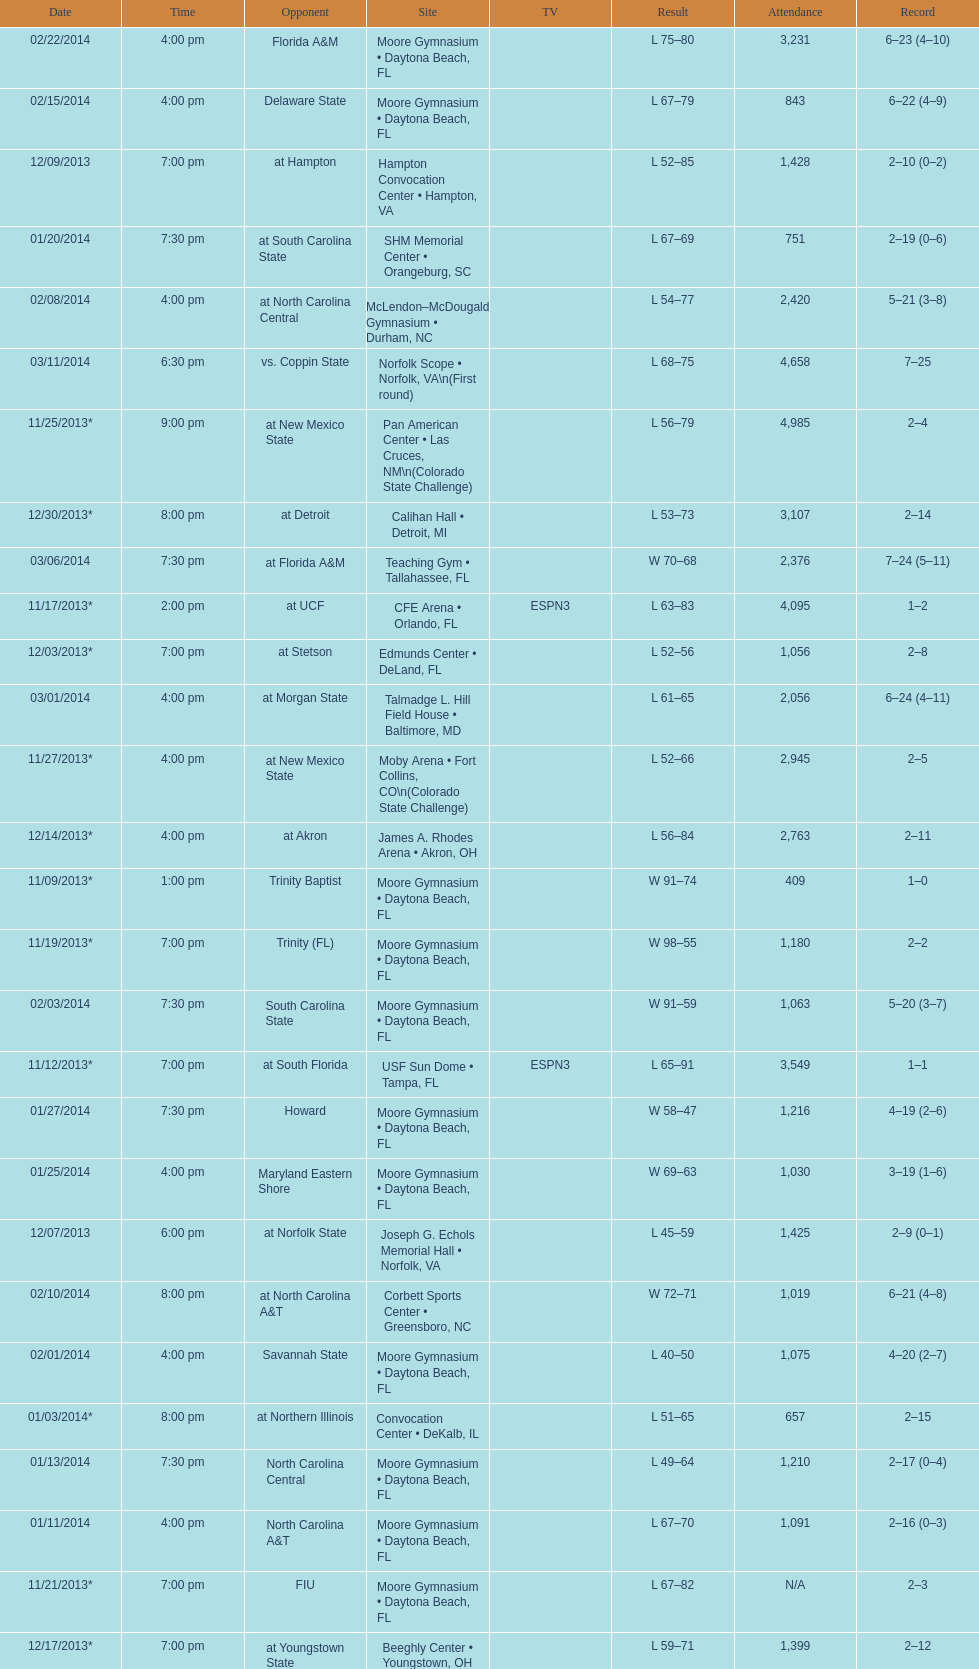Which game was later at night, fiu or northern colorado? Northern Colorado. 